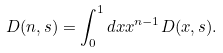<formula> <loc_0><loc_0><loc_500><loc_500>D ( n , s ) = \int \nolimits _ { 0 } ^ { 1 } d x x ^ { n - 1 } D ( x , s ) .</formula> 